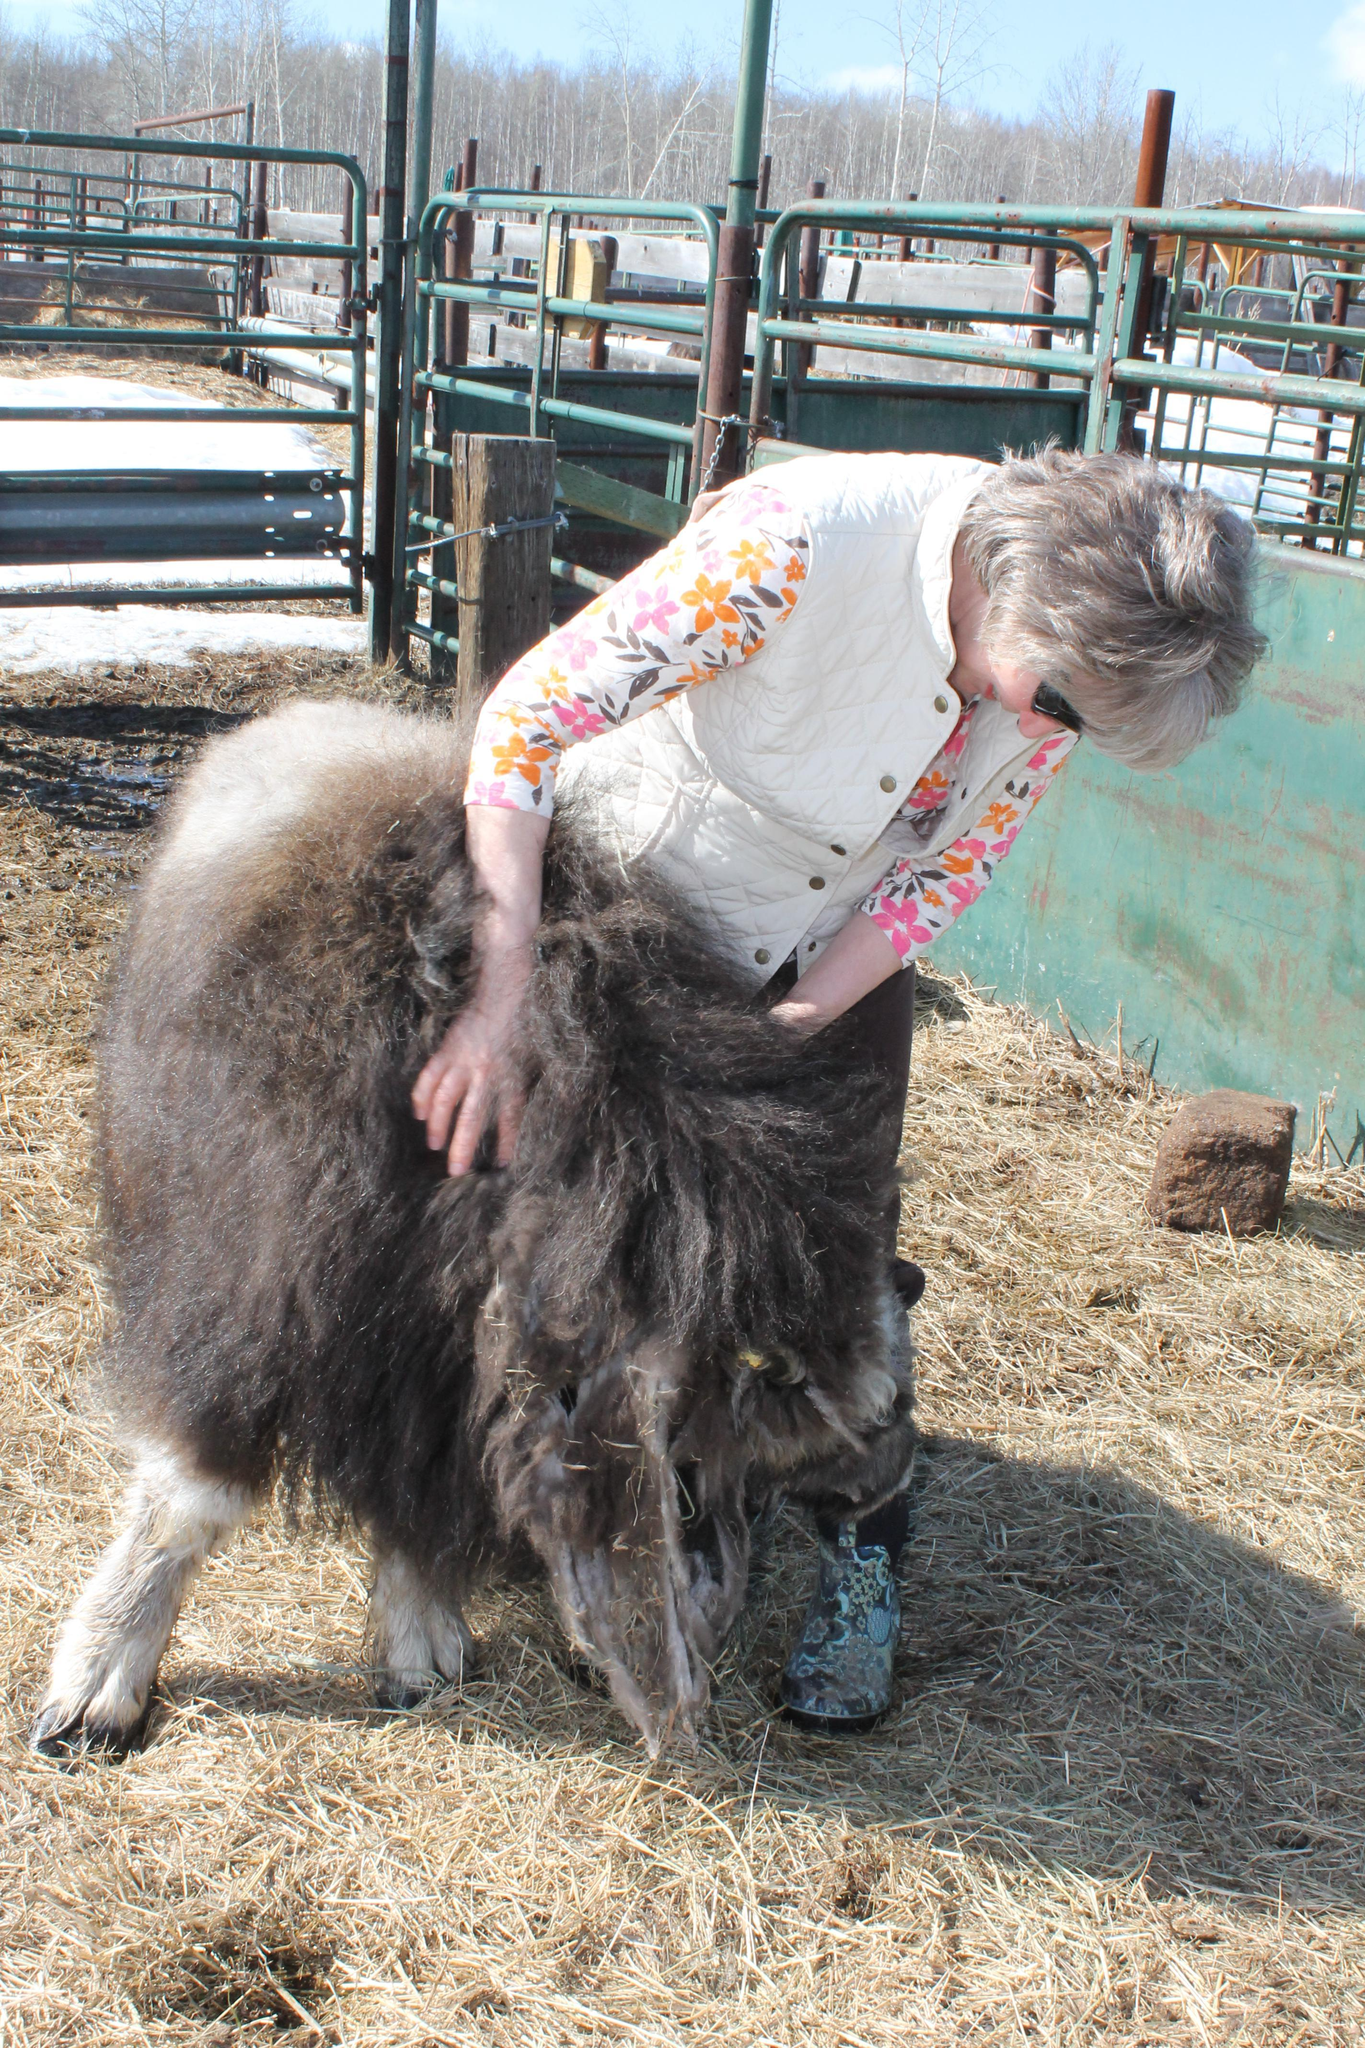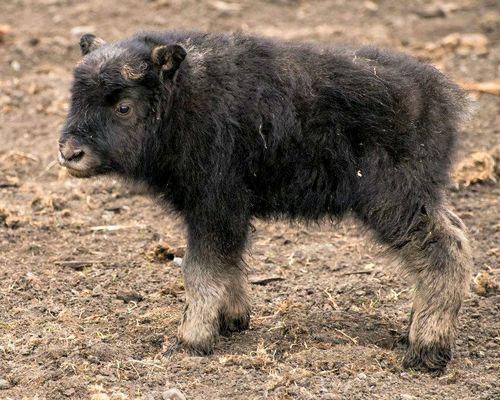The first image is the image on the left, the second image is the image on the right. Examine the images to the left and right. Is the description "An image shows at least one shaggy buffalo standing in a field in front of blue mountains, with fence posts on the right behind the animal." accurate? Answer yes or no. No. The first image is the image on the left, the second image is the image on the right. Analyze the images presented: Is the assertion "A single bull is walking past a metal fence in the image on the right." valid? Answer yes or no. No. 